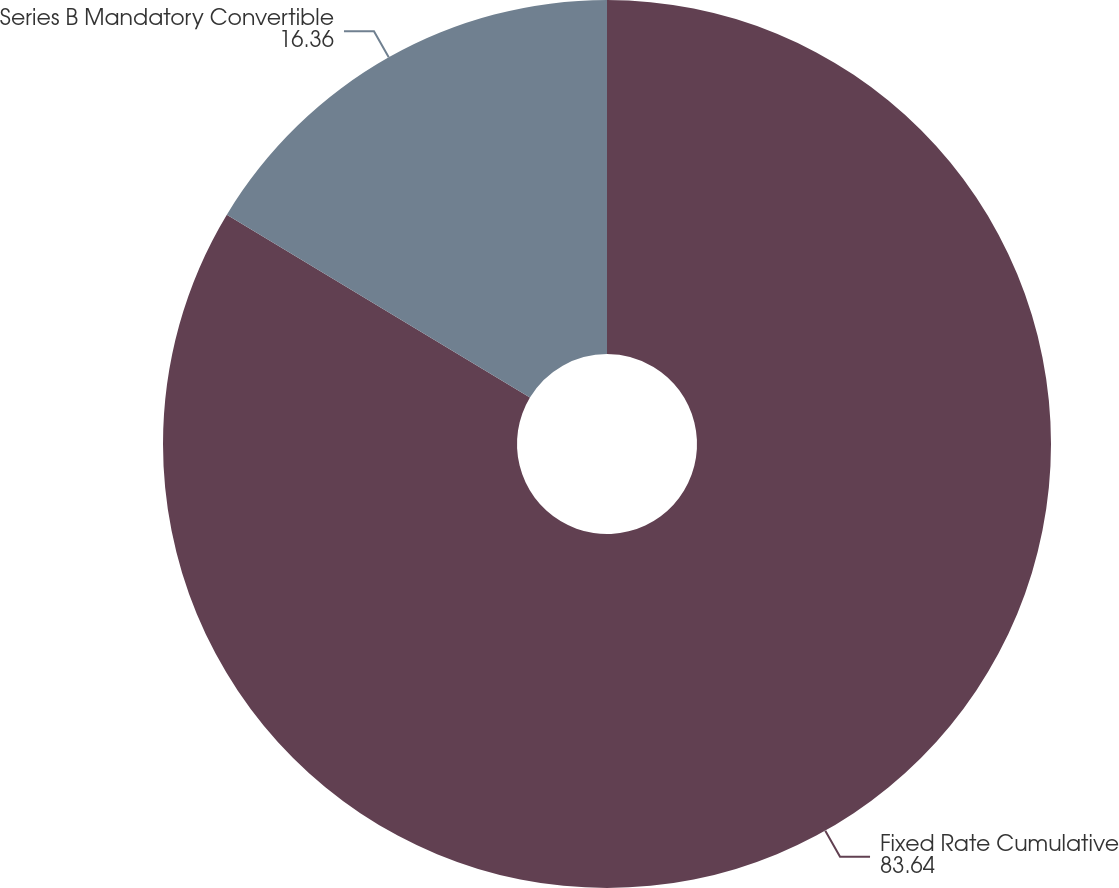Convert chart to OTSL. <chart><loc_0><loc_0><loc_500><loc_500><pie_chart><fcel>Fixed Rate Cumulative<fcel>Series B Mandatory Convertible<nl><fcel>83.64%<fcel>16.36%<nl></chart> 